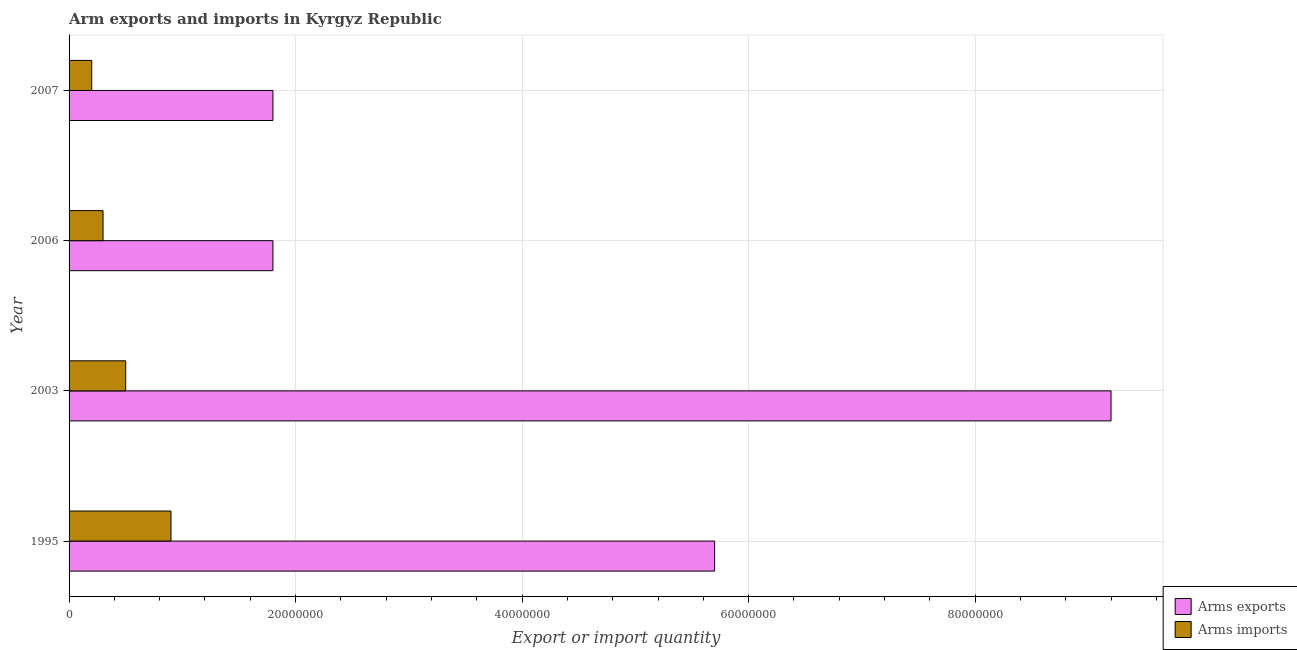How many different coloured bars are there?
Provide a short and direct response. 2. How many groups of bars are there?
Your response must be concise. 4. Are the number of bars on each tick of the Y-axis equal?
Ensure brevity in your answer.  Yes. How many bars are there on the 1st tick from the top?
Offer a terse response. 2. How many bars are there on the 2nd tick from the bottom?
Offer a terse response. 2. What is the label of the 3rd group of bars from the top?
Offer a very short reply. 2003. In how many cases, is the number of bars for a given year not equal to the number of legend labels?
Your answer should be very brief. 0. What is the arms imports in 2006?
Offer a terse response. 3.00e+06. Across all years, what is the maximum arms exports?
Give a very brief answer. 9.20e+07. Across all years, what is the minimum arms imports?
Your answer should be compact. 2.00e+06. In which year was the arms imports maximum?
Make the answer very short. 1995. In which year was the arms exports minimum?
Provide a succinct answer. 2006. What is the total arms imports in the graph?
Make the answer very short. 1.90e+07. What is the difference between the arms exports in 2003 and that in 2007?
Give a very brief answer. 7.40e+07. What is the difference between the arms imports in 2007 and the arms exports in 1995?
Provide a succinct answer. -5.50e+07. What is the average arms exports per year?
Provide a succinct answer. 4.62e+07. In the year 2006, what is the difference between the arms exports and arms imports?
Offer a very short reply. 1.50e+07. What is the ratio of the arms exports in 1995 to that in 2006?
Make the answer very short. 3.17. Is the arms imports in 1995 less than that in 2006?
Ensure brevity in your answer.  No. Is the difference between the arms exports in 1995 and 2007 greater than the difference between the arms imports in 1995 and 2007?
Your answer should be compact. Yes. What is the difference between the highest and the second highest arms exports?
Provide a short and direct response. 3.50e+07. What is the difference between the highest and the lowest arms imports?
Provide a succinct answer. 7.00e+06. Is the sum of the arms exports in 1995 and 2007 greater than the maximum arms imports across all years?
Make the answer very short. Yes. What does the 1st bar from the top in 2006 represents?
Your answer should be compact. Arms imports. What does the 1st bar from the bottom in 2006 represents?
Offer a terse response. Arms exports. How many bars are there?
Make the answer very short. 8. Are all the bars in the graph horizontal?
Ensure brevity in your answer.  Yes. What is the difference between two consecutive major ticks on the X-axis?
Keep it short and to the point. 2.00e+07. Are the values on the major ticks of X-axis written in scientific E-notation?
Ensure brevity in your answer.  No. How many legend labels are there?
Offer a very short reply. 2. What is the title of the graph?
Provide a short and direct response. Arm exports and imports in Kyrgyz Republic. Does "Long-term debt" appear as one of the legend labels in the graph?
Your answer should be compact. No. What is the label or title of the X-axis?
Provide a succinct answer. Export or import quantity. What is the label or title of the Y-axis?
Your answer should be compact. Year. What is the Export or import quantity of Arms exports in 1995?
Keep it short and to the point. 5.70e+07. What is the Export or import quantity in Arms imports in 1995?
Offer a very short reply. 9.00e+06. What is the Export or import quantity of Arms exports in 2003?
Your answer should be compact. 9.20e+07. What is the Export or import quantity of Arms exports in 2006?
Keep it short and to the point. 1.80e+07. What is the Export or import quantity in Arms imports in 2006?
Offer a very short reply. 3.00e+06. What is the Export or import quantity in Arms exports in 2007?
Your response must be concise. 1.80e+07. What is the Export or import quantity in Arms imports in 2007?
Provide a succinct answer. 2.00e+06. Across all years, what is the maximum Export or import quantity in Arms exports?
Give a very brief answer. 9.20e+07. Across all years, what is the maximum Export or import quantity in Arms imports?
Your response must be concise. 9.00e+06. Across all years, what is the minimum Export or import quantity in Arms exports?
Your answer should be compact. 1.80e+07. Across all years, what is the minimum Export or import quantity in Arms imports?
Provide a short and direct response. 2.00e+06. What is the total Export or import quantity of Arms exports in the graph?
Ensure brevity in your answer.  1.85e+08. What is the total Export or import quantity in Arms imports in the graph?
Your answer should be compact. 1.90e+07. What is the difference between the Export or import quantity of Arms exports in 1995 and that in 2003?
Your response must be concise. -3.50e+07. What is the difference between the Export or import quantity in Arms exports in 1995 and that in 2006?
Give a very brief answer. 3.90e+07. What is the difference between the Export or import quantity in Arms imports in 1995 and that in 2006?
Give a very brief answer. 6.00e+06. What is the difference between the Export or import quantity of Arms exports in 1995 and that in 2007?
Provide a short and direct response. 3.90e+07. What is the difference between the Export or import quantity of Arms imports in 1995 and that in 2007?
Your answer should be very brief. 7.00e+06. What is the difference between the Export or import quantity in Arms exports in 2003 and that in 2006?
Provide a short and direct response. 7.40e+07. What is the difference between the Export or import quantity of Arms exports in 2003 and that in 2007?
Give a very brief answer. 7.40e+07. What is the difference between the Export or import quantity of Arms imports in 2003 and that in 2007?
Offer a very short reply. 3.00e+06. What is the difference between the Export or import quantity in Arms exports in 2006 and that in 2007?
Give a very brief answer. 0. What is the difference between the Export or import quantity of Arms imports in 2006 and that in 2007?
Ensure brevity in your answer.  1.00e+06. What is the difference between the Export or import quantity in Arms exports in 1995 and the Export or import quantity in Arms imports in 2003?
Give a very brief answer. 5.20e+07. What is the difference between the Export or import quantity in Arms exports in 1995 and the Export or import quantity in Arms imports in 2006?
Keep it short and to the point. 5.40e+07. What is the difference between the Export or import quantity of Arms exports in 1995 and the Export or import quantity of Arms imports in 2007?
Give a very brief answer. 5.50e+07. What is the difference between the Export or import quantity of Arms exports in 2003 and the Export or import quantity of Arms imports in 2006?
Your answer should be very brief. 8.90e+07. What is the difference between the Export or import quantity in Arms exports in 2003 and the Export or import quantity in Arms imports in 2007?
Offer a terse response. 9.00e+07. What is the difference between the Export or import quantity of Arms exports in 2006 and the Export or import quantity of Arms imports in 2007?
Provide a succinct answer. 1.60e+07. What is the average Export or import quantity of Arms exports per year?
Provide a succinct answer. 4.62e+07. What is the average Export or import quantity of Arms imports per year?
Your answer should be very brief. 4.75e+06. In the year 1995, what is the difference between the Export or import quantity of Arms exports and Export or import quantity of Arms imports?
Give a very brief answer. 4.80e+07. In the year 2003, what is the difference between the Export or import quantity in Arms exports and Export or import quantity in Arms imports?
Offer a terse response. 8.70e+07. In the year 2006, what is the difference between the Export or import quantity in Arms exports and Export or import quantity in Arms imports?
Provide a short and direct response. 1.50e+07. In the year 2007, what is the difference between the Export or import quantity of Arms exports and Export or import quantity of Arms imports?
Give a very brief answer. 1.60e+07. What is the ratio of the Export or import quantity of Arms exports in 1995 to that in 2003?
Your answer should be very brief. 0.62. What is the ratio of the Export or import quantity of Arms imports in 1995 to that in 2003?
Offer a very short reply. 1.8. What is the ratio of the Export or import quantity in Arms exports in 1995 to that in 2006?
Your answer should be very brief. 3.17. What is the ratio of the Export or import quantity in Arms exports in 1995 to that in 2007?
Provide a short and direct response. 3.17. What is the ratio of the Export or import quantity of Arms imports in 1995 to that in 2007?
Offer a very short reply. 4.5. What is the ratio of the Export or import quantity in Arms exports in 2003 to that in 2006?
Your answer should be compact. 5.11. What is the ratio of the Export or import quantity in Arms exports in 2003 to that in 2007?
Your answer should be very brief. 5.11. What is the difference between the highest and the second highest Export or import quantity in Arms exports?
Keep it short and to the point. 3.50e+07. What is the difference between the highest and the lowest Export or import quantity in Arms exports?
Give a very brief answer. 7.40e+07. 